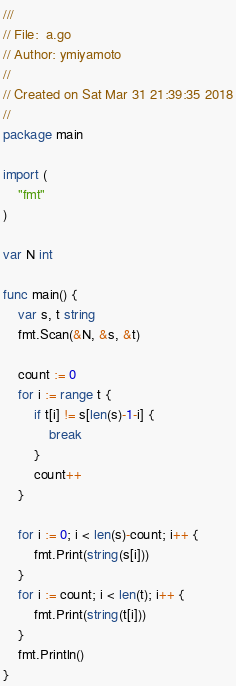Convert code to text. <code><loc_0><loc_0><loc_500><loc_500><_Go_>///
// File:  a.go
// Author: ymiyamoto
//
// Created on Sat Mar 31 21:39:35 2018
//
package main

import (
	"fmt"
)

var N int

func main() {
	var s, t string
	fmt.Scan(&N, &s, &t)

	count := 0
	for i := range t {
		if t[i] != s[len(s)-1-i] {
			break
		}
		count++
	}

	for i := 0; i < len(s)-count; i++ {
		fmt.Print(string(s[i]))
	}
	for i := count; i < len(t); i++ {
		fmt.Print(string(t[i]))
	}
	fmt.Println()
}
</code> 